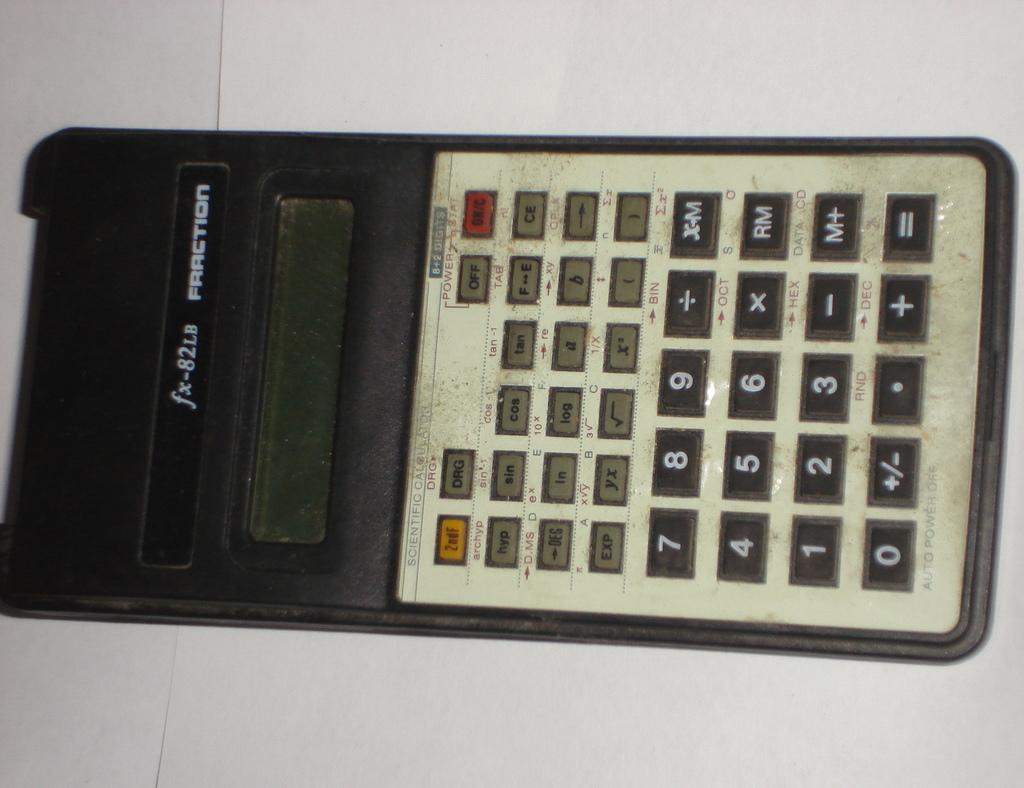<image>
Offer a succinct explanation of the picture presented. A dirty Fraction brand scientific calculator is turned off. 